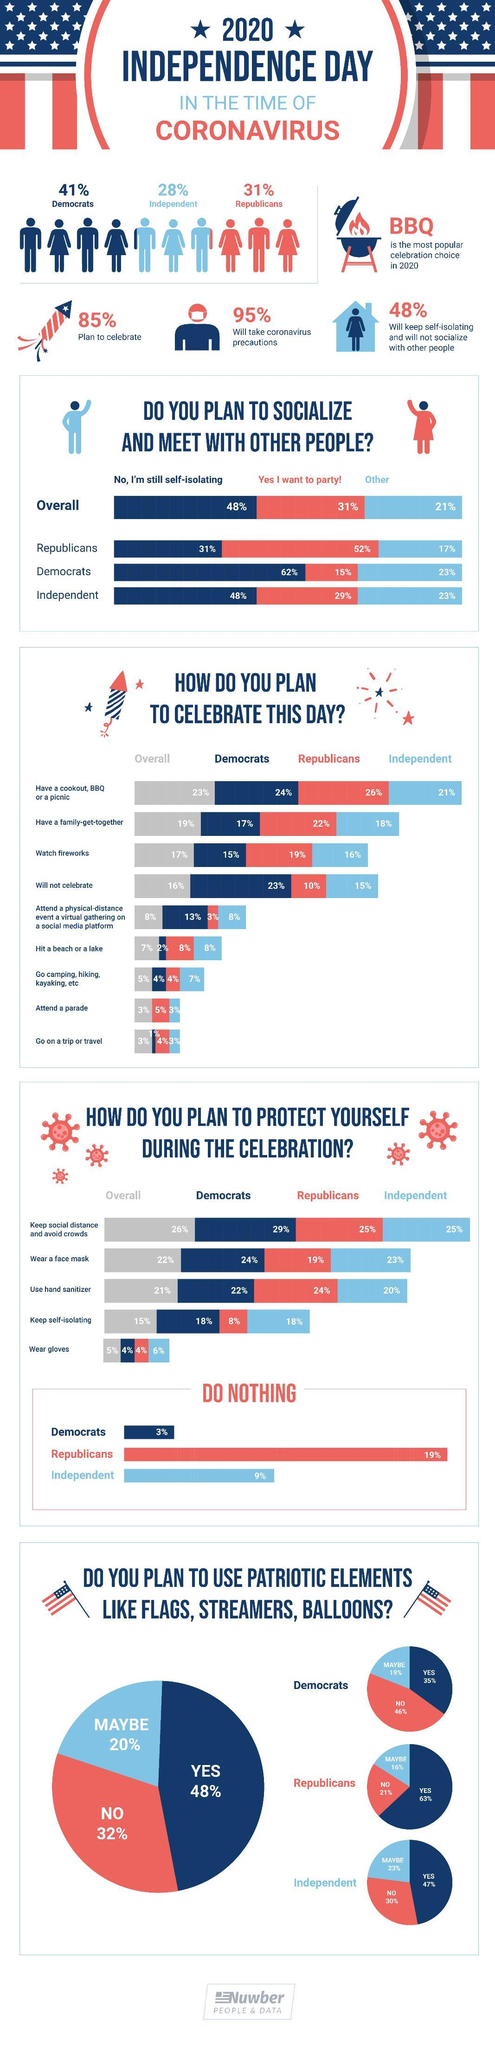What percent of Republicans plan to wear a face mask during the celebration to protect themselves from COVID-19?
Answer the question with a short phrase. 19% What percent of Republicans plan to have a family get-together to celebrate the independence day? 22% What percent of Democrats do not plan to celebrate the independence day amid COVID-19? 23% What percent of democrats want to party as a part of Independence day celebration? 15% What percent of the Americans are identified as Republicans? 31% What percent of the Americans are identified as Democrats? 41% What percent of the Americans will take COVID-19 precautions while celebrating the Independence day in 2020? 95% What percent of Republicans still follow self-isolation as COVID-19 precaution rather than partying? 31% What percent of the Americans do not plan to celebrate the independence day in 2020? 15% What percent of Democrats plan to use patriotic elements like flags, streamers & balloons during the celebration? 35% 